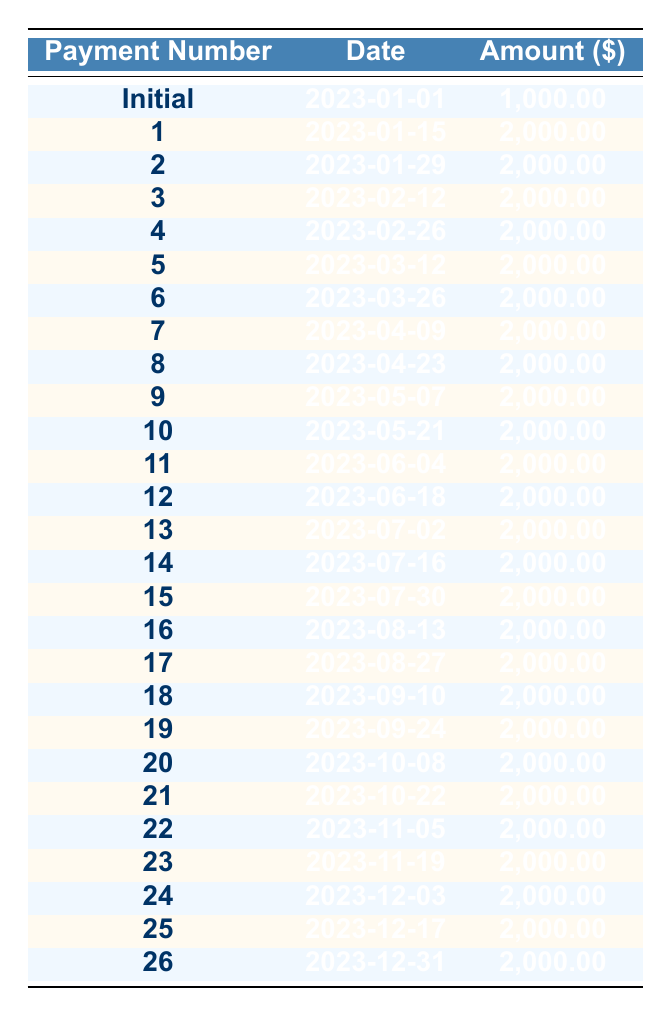What is the total amount paid over the 26 payments? To calculate the total amount paid, add the initial payment of 1,000 to the 25 subsequent payments of 2,000 each. This gives: 1,000 + (25 x 2,000) = 1,000 + 50,000 = 51,000.
Answer: 51,000 What is the payment amount for the second payment? The second payment is listed clearly in the table under the column "Amount ($)" for payment number 2, which is 2,000.
Answer: 2,000 How many payments were made after the initial payment? There are a total of 26 total payments, and the initial payment counts as one. Therefore, 26 - 1 = 25 subsequent payments were made.
Answer: 25 Is the amount of the first payment greater than the amount of subsequent payments? The first payment is 2,000, and all subsequent payments are also 2,000. Therefore, the first payment is not greater than subsequent payments; it is equal.
Answer: No What date is the last payment scheduled for? The last (26th) payment date is noted in the table as December 31, 2023.
Answer: December 31, 2023 What is the total amount paid in the first four payments? The total of the first four payments consists of the initial payment of 1,000 and the first three subsequent payments of 2,000 each. Calculation: 1,000 + (3 x 2,000) = 1,000 + 6,000 = 7,000.
Answer: 7,000 What is the average payment amount per payment? To find the average payment amount, sum up all payments (51,000) and divide by the total number of payments (26): 51,000 ÷ 26 = 1,961.54.
Answer: 1,961.54 Which payment number has the maximum payment amount? All payment amounts apart from the initial payment are equal to 2,000. Since the initial payment is 1,000, all payments from number 1 to 26 (after the initial) are the largest, so any payment from 1 to 26 can be considered.
Answer: Payment 1 to 26 have the maximum of 2,000 What was the net salary earned by the worker? The net salary is given in the data as 50,000, representing the total earnings after deductions.
Answer: 50,000 